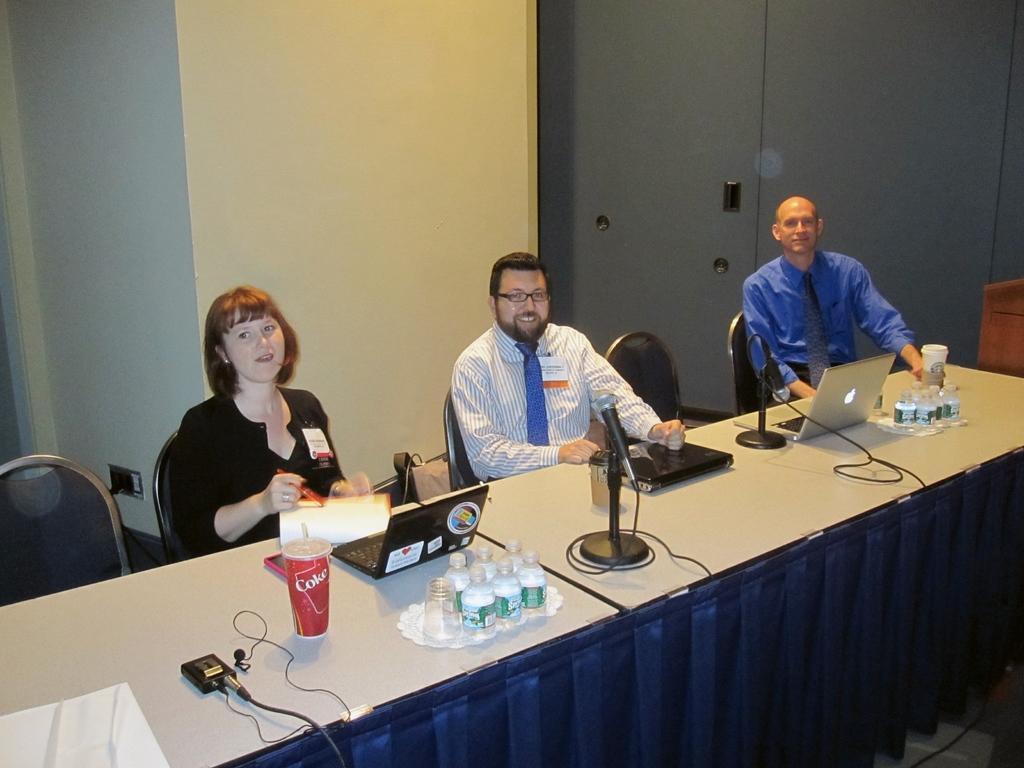Can you describe this image briefly? The persons are sitting in a room. There is a table. There is a coke ,laptop ,bottle and microphone on a table. We can see in the background there is a cupboard. 